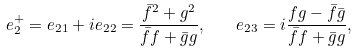Convert formula to latex. <formula><loc_0><loc_0><loc_500><loc_500>e _ { 2 } ^ { + } = e _ { 2 1 } + i e _ { 2 2 } = \frac { \bar { f } ^ { 2 } + g ^ { 2 } } { \bar { f } f + \bar { g } g } , \quad e _ { 2 3 } = i \frac { f g - \bar { f } \bar { g } } { \bar { f } f + \bar { g } g } ,</formula> 